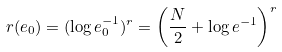<formula> <loc_0><loc_0><loc_500><loc_500>r ( e _ { 0 } ) = ( \log e _ { 0 } ^ { - 1 } ) ^ { r } = \left ( \frac { N } { 2 } + \log e ^ { - 1 } \right ) ^ { r }</formula> 